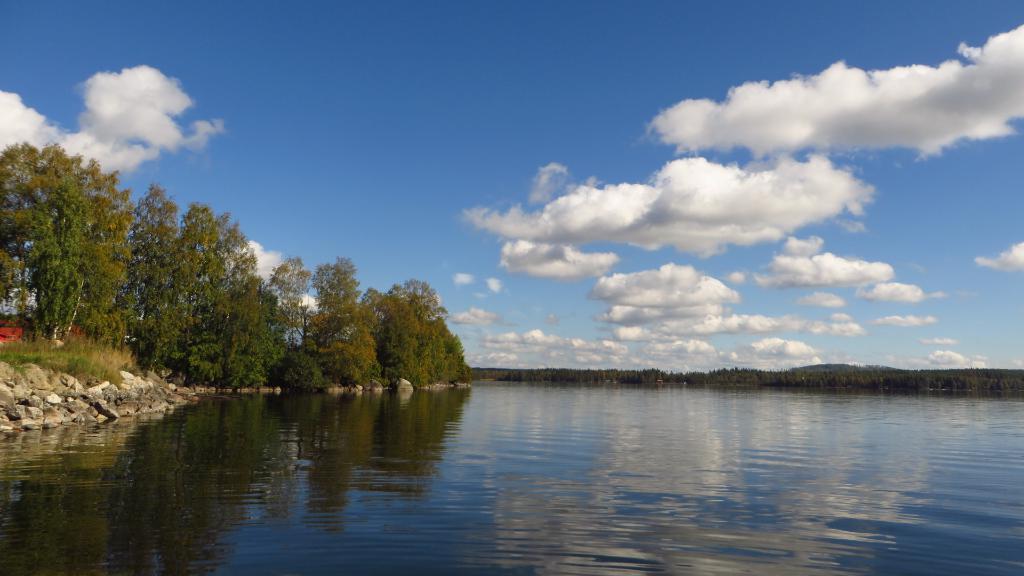In one or two sentences, can you explain what this image depicts? In this image we can see water, stones, grass, and trees. In the background there is sky with clouds. 